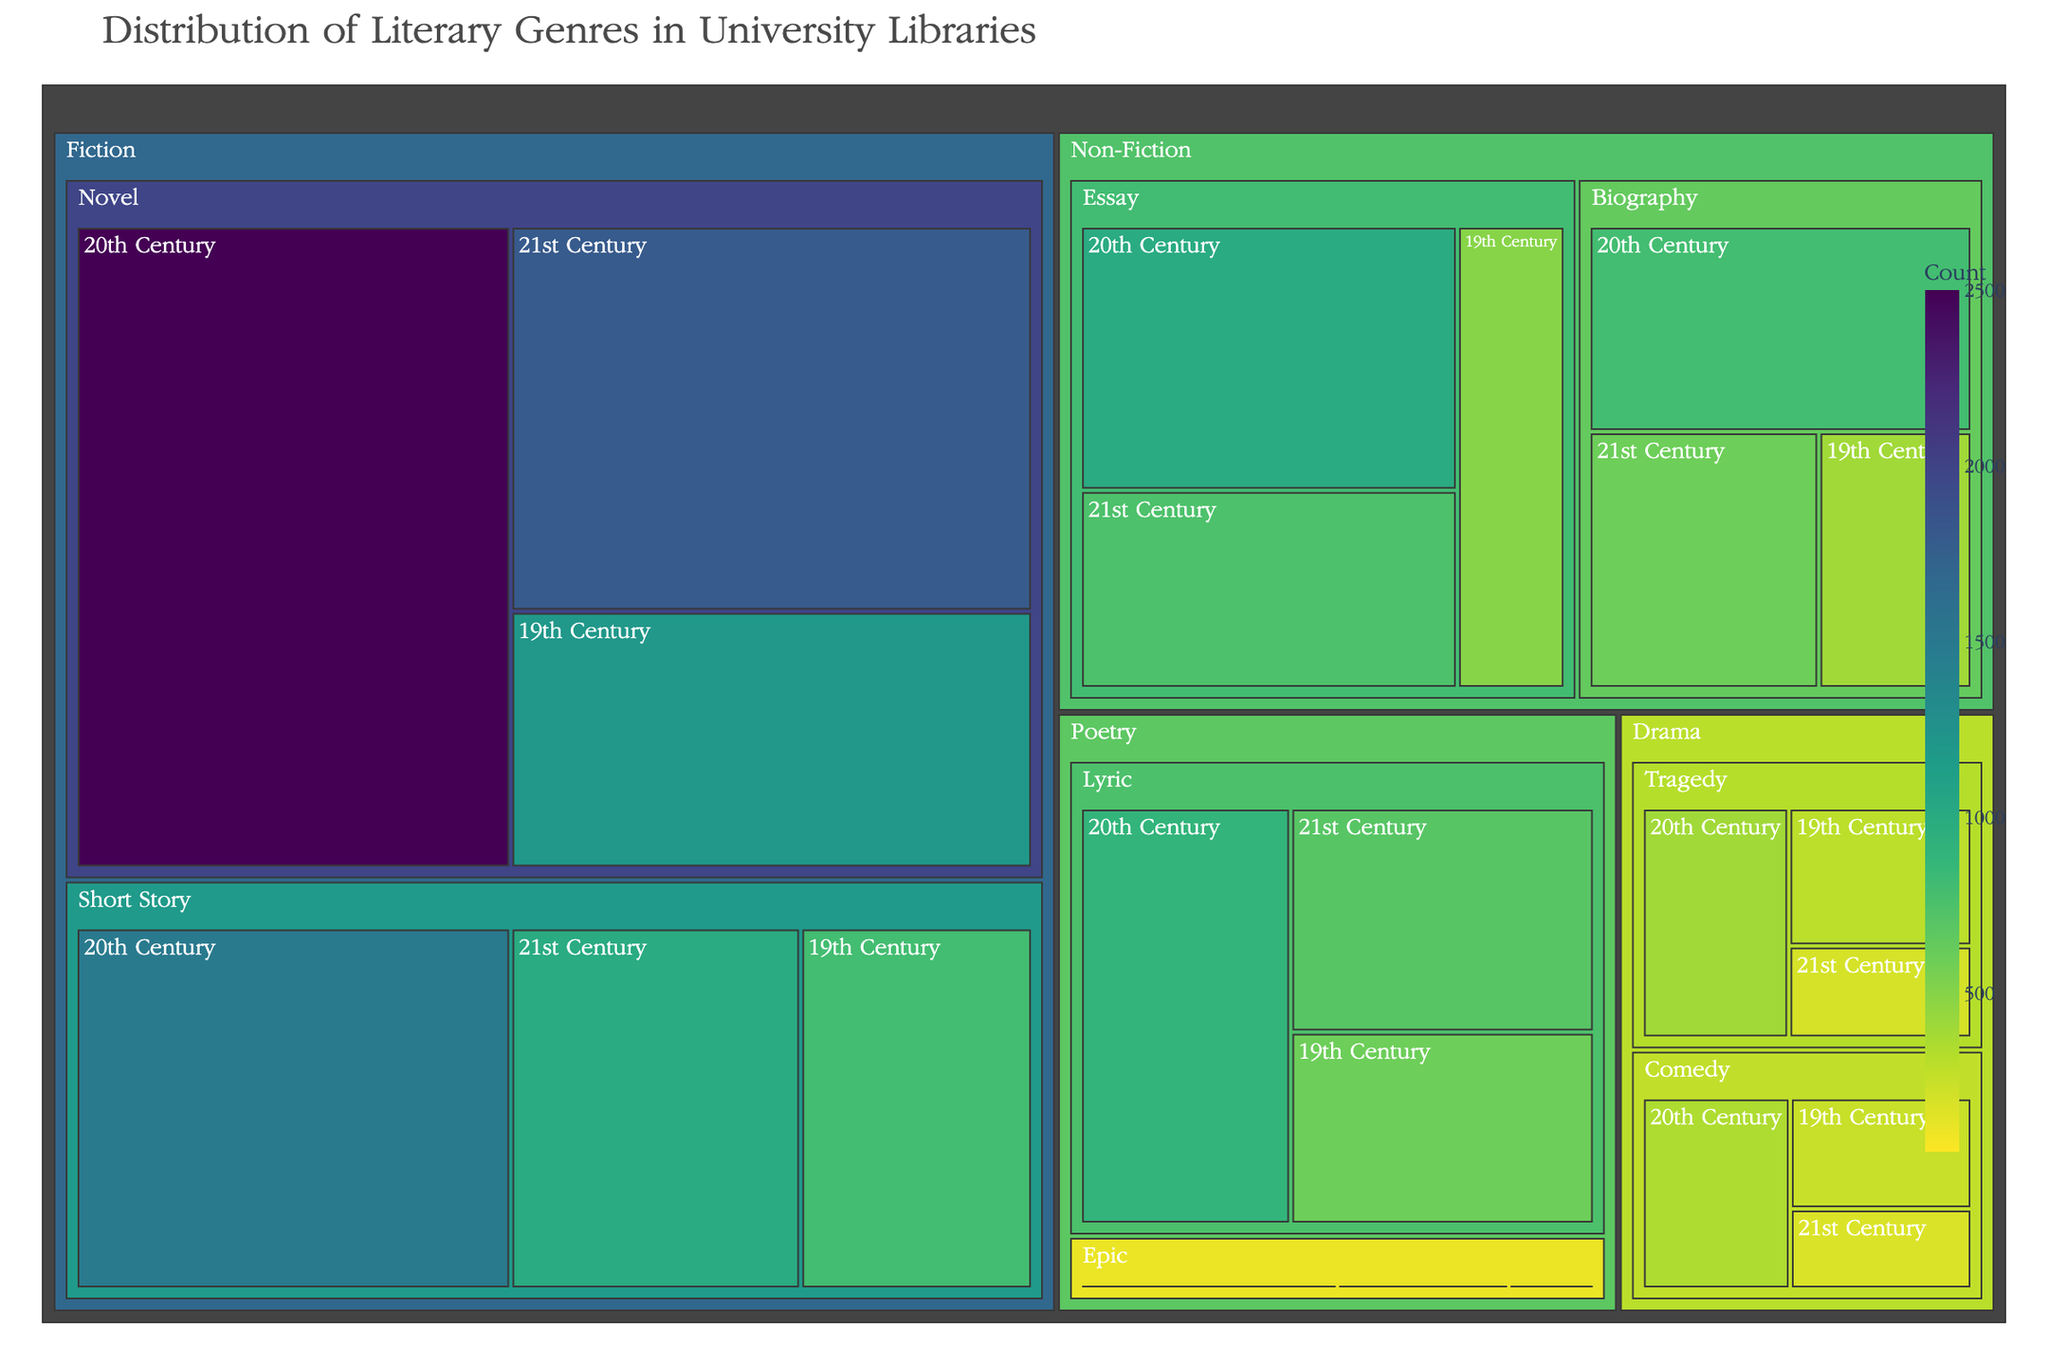what is the largest subgenre in terms of count within the Fiction genre for the 20th Century? To find the largest subgenre within the Fiction genre for the 20th Century, look at the blocks under "Fiction" category for the 20th Century. The "Novel" subgenre has a count of 2500, and "Short Story" subgenre has a count of 1500. Thus, "Novel" is the largest.
Answer: Novel Which subgenre in the Drama genre has the smallest count in the 21st Century? To determine the smallest subgenre in Drama for the 21st Century, examine the blocks under "Drama" category for the 21st Century. The counts are 200 for "Tragedy" and 180 for "Comedy". Therefore, "Comedy" has the smallest count.
Answer: Comedy How does the count of 21st Century Novels compare to 20th Century Novels in the Fiction genre? Compare the blocks under the "Novel" subgenre in the Fiction genre for both the 21st and 20th Centuries. The count for 21st Century Novels is 1800 while for 20th Century Novels it is 2500, indicating that the count of 21st Century Novels is lesser.
Answer: Lesser What is the overall count of Epic Poetry across all time periods? To find the total count of "Epic" Poetry, add the counts from 19th Century, 20th Century, and 21st Century in the Poetry genre. These are 150, 100, and 50 respectively. So, the total count is 150 + 100 + 50 = 300.
Answer: 300 In which time period is the count of Comedy in Drama genre the highest? Look at the counts for "Comedy" subgenre in Drama for each time period. The counts are 250 for 19th Century, 350 for 20th Century, and 180 for 21st Century. Therefore, the 20th Century has the highest count.
Answer: 20th Century What is the difference in count between 19th Century Short Stories and 21st Century Short Stories within the Fiction genre? Compare the counts of "Short Story" subgenre for 19th and 21st Centuries in Fiction. The counts are 800 for the 19th Century and 1000 for the 21st Century. The difference is 1000 - 800 = 200.
Answer: 200 Is the count of Lyric Poetry in the 20th Century higher or lower compared to the 21st Century? Compare the blocks under "Lyric" subgenre in Poetry for these centuries. The counts are 900 for the 20th Century and 700 for the 21st Century, indicating that the 20th Century is higher.
Answer: Higher What is the total count of Drama genre across all time periods? To find the total count for Drama, sum the counts of all subgenres across all time periods. Sum of "Tragedy" is 300 + 400 + 200 = 900, and sum of "Comedy" is 250 + 350 + 180 = 780. Therefore, the total count is 900 + 780 = 1680.
Answer: 1680 Which has more counts in the 19th Century, Non-Fiction or Poetry genres? Compare the total counts in the 19th Century for Non-Fiction and Poetry. Non-Fiction has counts of 400 for "Biography" and 500 for "Essay", totaling 400 + 500 = 900. Poetry has counts of 600 for "Lyric" and 150 for "Epic", totaling 600 + 150 = 750. Therefore, Non-Fiction has more counts.
Answer: Non-Fiction 